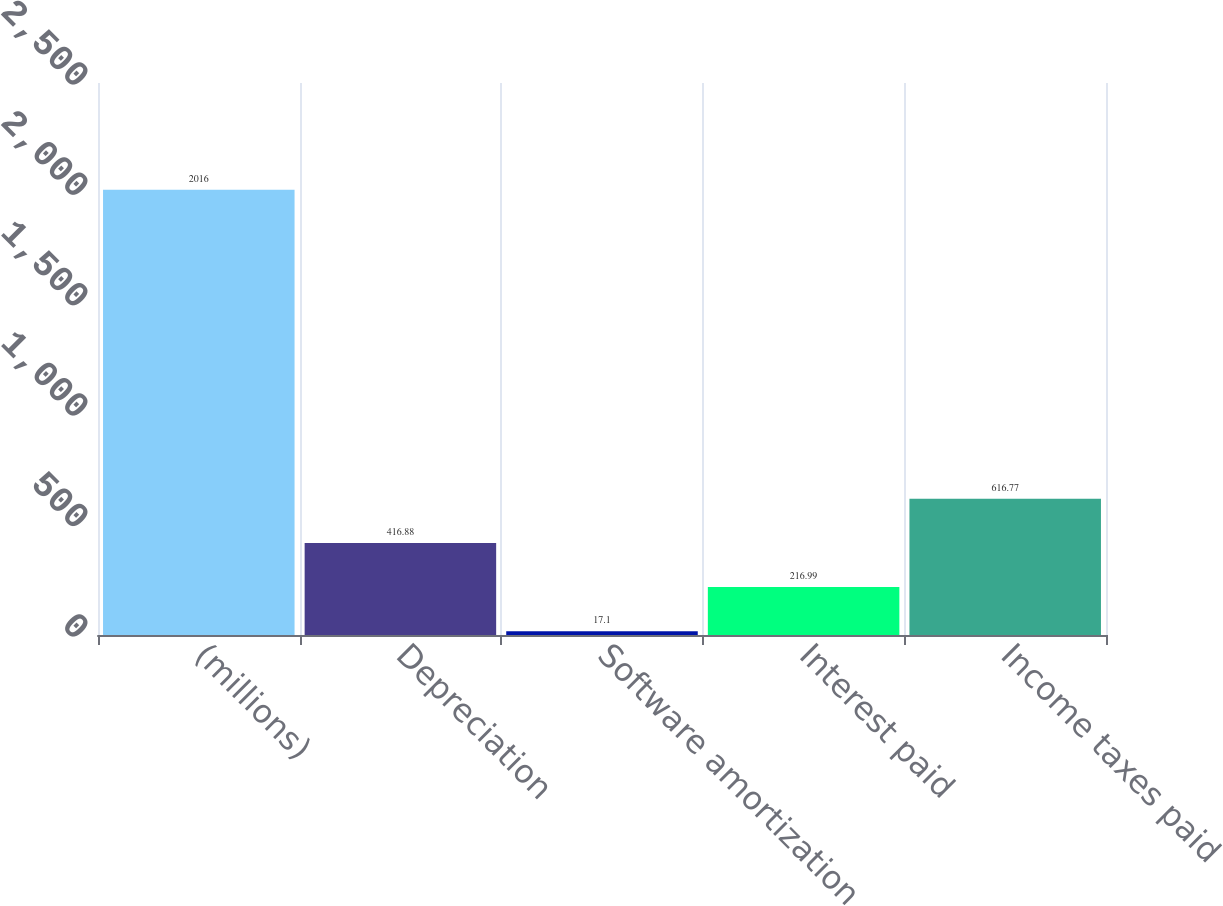<chart> <loc_0><loc_0><loc_500><loc_500><bar_chart><fcel>(millions)<fcel>Depreciation<fcel>Software amortization<fcel>Interest paid<fcel>Income taxes paid<nl><fcel>2016<fcel>416.88<fcel>17.1<fcel>216.99<fcel>616.77<nl></chart> 